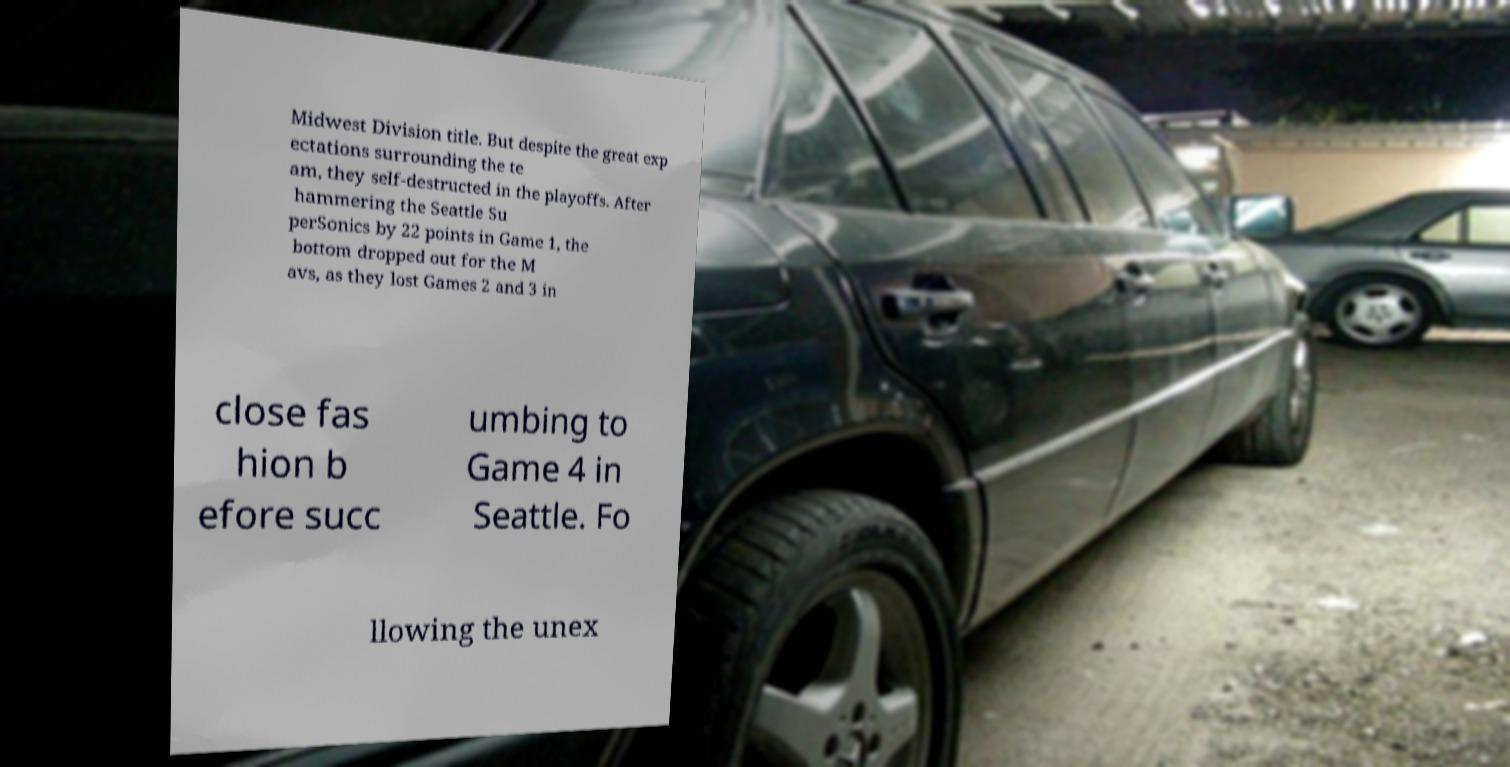Please identify and transcribe the text found in this image. Midwest Division title. But despite the great exp ectations surrounding the te am, they self-destructed in the playoffs. After hammering the Seattle Su perSonics by 22 points in Game 1, the bottom dropped out for the M avs, as they lost Games 2 and 3 in close fas hion b efore succ umbing to Game 4 in Seattle. Fo llowing the unex 